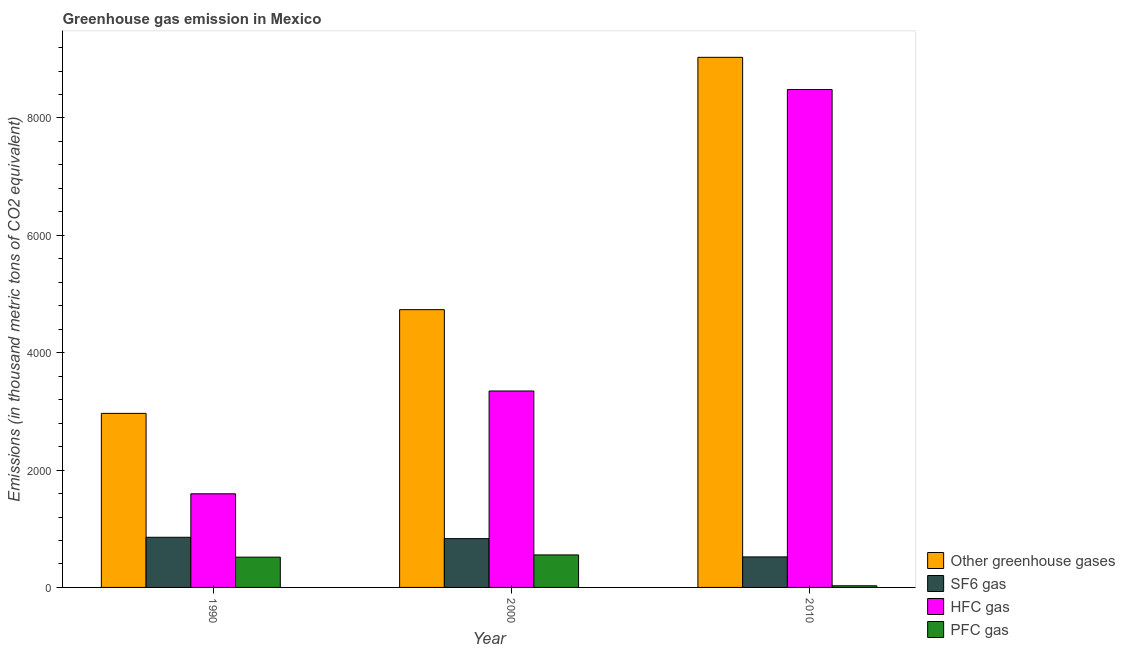How many groups of bars are there?
Offer a terse response. 3. Are the number of bars per tick equal to the number of legend labels?
Provide a short and direct response. Yes. How many bars are there on the 2nd tick from the right?
Offer a very short reply. 4. In how many cases, is the number of bars for a given year not equal to the number of legend labels?
Your response must be concise. 0. What is the emission of greenhouse gases in 1990?
Your answer should be very brief. 2965.8. Across all years, what is the maximum emission of greenhouse gases?
Make the answer very short. 9033. Across all years, what is the minimum emission of sf6 gas?
Provide a short and direct response. 520. In which year was the emission of pfc gas maximum?
Make the answer very short. 2000. What is the total emission of pfc gas in the graph?
Ensure brevity in your answer.  1098.1. What is the difference between the emission of greenhouse gases in 2000 and that in 2010?
Provide a succinct answer. -4299.8. What is the difference between the emission of hfc gas in 2010 and the emission of pfc gas in 1990?
Your response must be concise. 6889.7. What is the average emission of pfc gas per year?
Your response must be concise. 366.03. In how many years, is the emission of pfc gas greater than 5200 thousand metric tons?
Your response must be concise. 0. What is the ratio of the emission of hfc gas in 2000 to that in 2010?
Offer a terse response. 0.39. What is the difference between the highest and the second highest emission of pfc gas?
Provide a short and direct response. 38.1. What is the difference between the highest and the lowest emission of hfc gas?
Your answer should be compact. 6889.7. Is it the case that in every year, the sum of the emission of hfc gas and emission of greenhouse gases is greater than the sum of emission of sf6 gas and emission of pfc gas?
Offer a terse response. No. What does the 3rd bar from the left in 1990 represents?
Make the answer very short. HFC gas. What does the 1st bar from the right in 1990 represents?
Your response must be concise. PFC gas. Is it the case that in every year, the sum of the emission of greenhouse gases and emission of sf6 gas is greater than the emission of hfc gas?
Your response must be concise. Yes. Are all the bars in the graph horizontal?
Your response must be concise. No. Are the values on the major ticks of Y-axis written in scientific E-notation?
Provide a short and direct response. No. Does the graph contain any zero values?
Offer a very short reply. No. How are the legend labels stacked?
Your response must be concise. Vertical. What is the title of the graph?
Make the answer very short. Greenhouse gas emission in Mexico. Does "Rule based governance" appear as one of the legend labels in the graph?
Offer a very short reply. No. What is the label or title of the Y-axis?
Your answer should be very brief. Emissions (in thousand metric tons of CO2 equivalent). What is the Emissions (in thousand metric tons of CO2 equivalent) in Other greenhouse gases in 1990?
Offer a very short reply. 2965.8. What is the Emissions (in thousand metric tons of CO2 equivalent) in SF6 gas in 1990?
Your answer should be very brief. 854.5. What is the Emissions (in thousand metric tons of CO2 equivalent) of HFC gas in 1990?
Provide a succinct answer. 1595.3. What is the Emissions (in thousand metric tons of CO2 equivalent) of PFC gas in 1990?
Keep it short and to the point. 516. What is the Emissions (in thousand metric tons of CO2 equivalent) in Other greenhouse gases in 2000?
Your response must be concise. 4733.2. What is the Emissions (in thousand metric tons of CO2 equivalent) of SF6 gas in 2000?
Your answer should be very brief. 831.8. What is the Emissions (in thousand metric tons of CO2 equivalent) in HFC gas in 2000?
Offer a very short reply. 3347.3. What is the Emissions (in thousand metric tons of CO2 equivalent) in PFC gas in 2000?
Keep it short and to the point. 554.1. What is the Emissions (in thousand metric tons of CO2 equivalent) of Other greenhouse gases in 2010?
Ensure brevity in your answer.  9033. What is the Emissions (in thousand metric tons of CO2 equivalent) in SF6 gas in 2010?
Keep it short and to the point. 520. What is the Emissions (in thousand metric tons of CO2 equivalent) of HFC gas in 2010?
Ensure brevity in your answer.  8485. What is the Emissions (in thousand metric tons of CO2 equivalent) in PFC gas in 2010?
Your response must be concise. 28. Across all years, what is the maximum Emissions (in thousand metric tons of CO2 equivalent) of Other greenhouse gases?
Make the answer very short. 9033. Across all years, what is the maximum Emissions (in thousand metric tons of CO2 equivalent) of SF6 gas?
Give a very brief answer. 854.5. Across all years, what is the maximum Emissions (in thousand metric tons of CO2 equivalent) of HFC gas?
Offer a terse response. 8485. Across all years, what is the maximum Emissions (in thousand metric tons of CO2 equivalent) of PFC gas?
Your answer should be compact. 554.1. Across all years, what is the minimum Emissions (in thousand metric tons of CO2 equivalent) of Other greenhouse gases?
Make the answer very short. 2965.8. Across all years, what is the minimum Emissions (in thousand metric tons of CO2 equivalent) in SF6 gas?
Ensure brevity in your answer.  520. Across all years, what is the minimum Emissions (in thousand metric tons of CO2 equivalent) in HFC gas?
Make the answer very short. 1595.3. Across all years, what is the minimum Emissions (in thousand metric tons of CO2 equivalent) of PFC gas?
Keep it short and to the point. 28. What is the total Emissions (in thousand metric tons of CO2 equivalent) of Other greenhouse gases in the graph?
Make the answer very short. 1.67e+04. What is the total Emissions (in thousand metric tons of CO2 equivalent) of SF6 gas in the graph?
Provide a short and direct response. 2206.3. What is the total Emissions (in thousand metric tons of CO2 equivalent) of HFC gas in the graph?
Your answer should be very brief. 1.34e+04. What is the total Emissions (in thousand metric tons of CO2 equivalent) in PFC gas in the graph?
Ensure brevity in your answer.  1098.1. What is the difference between the Emissions (in thousand metric tons of CO2 equivalent) in Other greenhouse gases in 1990 and that in 2000?
Offer a very short reply. -1767.4. What is the difference between the Emissions (in thousand metric tons of CO2 equivalent) of SF6 gas in 1990 and that in 2000?
Your answer should be compact. 22.7. What is the difference between the Emissions (in thousand metric tons of CO2 equivalent) in HFC gas in 1990 and that in 2000?
Keep it short and to the point. -1752. What is the difference between the Emissions (in thousand metric tons of CO2 equivalent) of PFC gas in 1990 and that in 2000?
Give a very brief answer. -38.1. What is the difference between the Emissions (in thousand metric tons of CO2 equivalent) in Other greenhouse gases in 1990 and that in 2010?
Make the answer very short. -6067.2. What is the difference between the Emissions (in thousand metric tons of CO2 equivalent) of SF6 gas in 1990 and that in 2010?
Give a very brief answer. 334.5. What is the difference between the Emissions (in thousand metric tons of CO2 equivalent) of HFC gas in 1990 and that in 2010?
Your answer should be very brief. -6889.7. What is the difference between the Emissions (in thousand metric tons of CO2 equivalent) in PFC gas in 1990 and that in 2010?
Offer a terse response. 488. What is the difference between the Emissions (in thousand metric tons of CO2 equivalent) in Other greenhouse gases in 2000 and that in 2010?
Your answer should be compact. -4299.8. What is the difference between the Emissions (in thousand metric tons of CO2 equivalent) in SF6 gas in 2000 and that in 2010?
Give a very brief answer. 311.8. What is the difference between the Emissions (in thousand metric tons of CO2 equivalent) in HFC gas in 2000 and that in 2010?
Give a very brief answer. -5137.7. What is the difference between the Emissions (in thousand metric tons of CO2 equivalent) in PFC gas in 2000 and that in 2010?
Offer a very short reply. 526.1. What is the difference between the Emissions (in thousand metric tons of CO2 equivalent) in Other greenhouse gases in 1990 and the Emissions (in thousand metric tons of CO2 equivalent) in SF6 gas in 2000?
Your response must be concise. 2134. What is the difference between the Emissions (in thousand metric tons of CO2 equivalent) of Other greenhouse gases in 1990 and the Emissions (in thousand metric tons of CO2 equivalent) of HFC gas in 2000?
Give a very brief answer. -381.5. What is the difference between the Emissions (in thousand metric tons of CO2 equivalent) in Other greenhouse gases in 1990 and the Emissions (in thousand metric tons of CO2 equivalent) in PFC gas in 2000?
Provide a succinct answer. 2411.7. What is the difference between the Emissions (in thousand metric tons of CO2 equivalent) in SF6 gas in 1990 and the Emissions (in thousand metric tons of CO2 equivalent) in HFC gas in 2000?
Make the answer very short. -2492.8. What is the difference between the Emissions (in thousand metric tons of CO2 equivalent) of SF6 gas in 1990 and the Emissions (in thousand metric tons of CO2 equivalent) of PFC gas in 2000?
Your answer should be compact. 300.4. What is the difference between the Emissions (in thousand metric tons of CO2 equivalent) in HFC gas in 1990 and the Emissions (in thousand metric tons of CO2 equivalent) in PFC gas in 2000?
Your answer should be compact. 1041.2. What is the difference between the Emissions (in thousand metric tons of CO2 equivalent) of Other greenhouse gases in 1990 and the Emissions (in thousand metric tons of CO2 equivalent) of SF6 gas in 2010?
Your response must be concise. 2445.8. What is the difference between the Emissions (in thousand metric tons of CO2 equivalent) of Other greenhouse gases in 1990 and the Emissions (in thousand metric tons of CO2 equivalent) of HFC gas in 2010?
Make the answer very short. -5519.2. What is the difference between the Emissions (in thousand metric tons of CO2 equivalent) in Other greenhouse gases in 1990 and the Emissions (in thousand metric tons of CO2 equivalent) in PFC gas in 2010?
Provide a succinct answer. 2937.8. What is the difference between the Emissions (in thousand metric tons of CO2 equivalent) in SF6 gas in 1990 and the Emissions (in thousand metric tons of CO2 equivalent) in HFC gas in 2010?
Make the answer very short. -7630.5. What is the difference between the Emissions (in thousand metric tons of CO2 equivalent) of SF6 gas in 1990 and the Emissions (in thousand metric tons of CO2 equivalent) of PFC gas in 2010?
Ensure brevity in your answer.  826.5. What is the difference between the Emissions (in thousand metric tons of CO2 equivalent) in HFC gas in 1990 and the Emissions (in thousand metric tons of CO2 equivalent) in PFC gas in 2010?
Keep it short and to the point. 1567.3. What is the difference between the Emissions (in thousand metric tons of CO2 equivalent) of Other greenhouse gases in 2000 and the Emissions (in thousand metric tons of CO2 equivalent) of SF6 gas in 2010?
Your answer should be very brief. 4213.2. What is the difference between the Emissions (in thousand metric tons of CO2 equivalent) of Other greenhouse gases in 2000 and the Emissions (in thousand metric tons of CO2 equivalent) of HFC gas in 2010?
Make the answer very short. -3751.8. What is the difference between the Emissions (in thousand metric tons of CO2 equivalent) of Other greenhouse gases in 2000 and the Emissions (in thousand metric tons of CO2 equivalent) of PFC gas in 2010?
Your answer should be very brief. 4705.2. What is the difference between the Emissions (in thousand metric tons of CO2 equivalent) of SF6 gas in 2000 and the Emissions (in thousand metric tons of CO2 equivalent) of HFC gas in 2010?
Your response must be concise. -7653.2. What is the difference between the Emissions (in thousand metric tons of CO2 equivalent) in SF6 gas in 2000 and the Emissions (in thousand metric tons of CO2 equivalent) in PFC gas in 2010?
Your answer should be very brief. 803.8. What is the difference between the Emissions (in thousand metric tons of CO2 equivalent) in HFC gas in 2000 and the Emissions (in thousand metric tons of CO2 equivalent) in PFC gas in 2010?
Ensure brevity in your answer.  3319.3. What is the average Emissions (in thousand metric tons of CO2 equivalent) in Other greenhouse gases per year?
Make the answer very short. 5577.33. What is the average Emissions (in thousand metric tons of CO2 equivalent) in SF6 gas per year?
Ensure brevity in your answer.  735.43. What is the average Emissions (in thousand metric tons of CO2 equivalent) of HFC gas per year?
Provide a short and direct response. 4475.87. What is the average Emissions (in thousand metric tons of CO2 equivalent) in PFC gas per year?
Your response must be concise. 366.03. In the year 1990, what is the difference between the Emissions (in thousand metric tons of CO2 equivalent) in Other greenhouse gases and Emissions (in thousand metric tons of CO2 equivalent) in SF6 gas?
Provide a short and direct response. 2111.3. In the year 1990, what is the difference between the Emissions (in thousand metric tons of CO2 equivalent) of Other greenhouse gases and Emissions (in thousand metric tons of CO2 equivalent) of HFC gas?
Give a very brief answer. 1370.5. In the year 1990, what is the difference between the Emissions (in thousand metric tons of CO2 equivalent) of Other greenhouse gases and Emissions (in thousand metric tons of CO2 equivalent) of PFC gas?
Keep it short and to the point. 2449.8. In the year 1990, what is the difference between the Emissions (in thousand metric tons of CO2 equivalent) in SF6 gas and Emissions (in thousand metric tons of CO2 equivalent) in HFC gas?
Offer a very short reply. -740.8. In the year 1990, what is the difference between the Emissions (in thousand metric tons of CO2 equivalent) of SF6 gas and Emissions (in thousand metric tons of CO2 equivalent) of PFC gas?
Ensure brevity in your answer.  338.5. In the year 1990, what is the difference between the Emissions (in thousand metric tons of CO2 equivalent) of HFC gas and Emissions (in thousand metric tons of CO2 equivalent) of PFC gas?
Provide a succinct answer. 1079.3. In the year 2000, what is the difference between the Emissions (in thousand metric tons of CO2 equivalent) in Other greenhouse gases and Emissions (in thousand metric tons of CO2 equivalent) in SF6 gas?
Give a very brief answer. 3901.4. In the year 2000, what is the difference between the Emissions (in thousand metric tons of CO2 equivalent) in Other greenhouse gases and Emissions (in thousand metric tons of CO2 equivalent) in HFC gas?
Your answer should be very brief. 1385.9. In the year 2000, what is the difference between the Emissions (in thousand metric tons of CO2 equivalent) in Other greenhouse gases and Emissions (in thousand metric tons of CO2 equivalent) in PFC gas?
Offer a very short reply. 4179.1. In the year 2000, what is the difference between the Emissions (in thousand metric tons of CO2 equivalent) of SF6 gas and Emissions (in thousand metric tons of CO2 equivalent) of HFC gas?
Give a very brief answer. -2515.5. In the year 2000, what is the difference between the Emissions (in thousand metric tons of CO2 equivalent) in SF6 gas and Emissions (in thousand metric tons of CO2 equivalent) in PFC gas?
Provide a succinct answer. 277.7. In the year 2000, what is the difference between the Emissions (in thousand metric tons of CO2 equivalent) of HFC gas and Emissions (in thousand metric tons of CO2 equivalent) of PFC gas?
Your response must be concise. 2793.2. In the year 2010, what is the difference between the Emissions (in thousand metric tons of CO2 equivalent) in Other greenhouse gases and Emissions (in thousand metric tons of CO2 equivalent) in SF6 gas?
Provide a succinct answer. 8513. In the year 2010, what is the difference between the Emissions (in thousand metric tons of CO2 equivalent) of Other greenhouse gases and Emissions (in thousand metric tons of CO2 equivalent) of HFC gas?
Give a very brief answer. 548. In the year 2010, what is the difference between the Emissions (in thousand metric tons of CO2 equivalent) of Other greenhouse gases and Emissions (in thousand metric tons of CO2 equivalent) of PFC gas?
Your answer should be compact. 9005. In the year 2010, what is the difference between the Emissions (in thousand metric tons of CO2 equivalent) of SF6 gas and Emissions (in thousand metric tons of CO2 equivalent) of HFC gas?
Make the answer very short. -7965. In the year 2010, what is the difference between the Emissions (in thousand metric tons of CO2 equivalent) in SF6 gas and Emissions (in thousand metric tons of CO2 equivalent) in PFC gas?
Give a very brief answer. 492. In the year 2010, what is the difference between the Emissions (in thousand metric tons of CO2 equivalent) of HFC gas and Emissions (in thousand metric tons of CO2 equivalent) of PFC gas?
Offer a terse response. 8457. What is the ratio of the Emissions (in thousand metric tons of CO2 equivalent) in Other greenhouse gases in 1990 to that in 2000?
Offer a terse response. 0.63. What is the ratio of the Emissions (in thousand metric tons of CO2 equivalent) in SF6 gas in 1990 to that in 2000?
Offer a very short reply. 1.03. What is the ratio of the Emissions (in thousand metric tons of CO2 equivalent) in HFC gas in 1990 to that in 2000?
Provide a short and direct response. 0.48. What is the ratio of the Emissions (in thousand metric tons of CO2 equivalent) of PFC gas in 1990 to that in 2000?
Your answer should be very brief. 0.93. What is the ratio of the Emissions (in thousand metric tons of CO2 equivalent) of Other greenhouse gases in 1990 to that in 2010?
Provide a succinct answer. 0.33. What is the ratio of the Emissions (in thousand metric tons of CO2 equivalent) of SF6 gas in 1990 to that in 2010?
Make the answer very short. 1.64. What is the ratio of the Emissions (in thousand metric tons of CO2 equivalent) of HFC gas in 1990 to that in 2010?
Give a very brief answer. 0.19. What is the ratio of the Emissions (in thousand metric tons of CO2 equivalent) of PFC gas in 1990 to that in 2010?
Give a very brief answer. 18.43. What is the ratio of the Emissions (in thousand metric tons of CO2 equivalent) in Other greenhouse gases in 2000 to that in 2010?
Your response must be concise. 0.52. What is the ratio of the Emissions (in thousand metric tons of CO2 equivalent) of SF6 gas in 2000 to that in 2010?
Provide a succinct answer. 1.6. What is the ratio of the Emissions (in thousand metric tons of CO2 equivalent) of HFC gas in 2000 to that in 2010?
Make the answer very short. 0.39. What is the ratio of the Emissions (in thousand metric tons of CO2 equivalent) in PFC gas in 2000 to that in 2010?
Your answer should be very brief. 19.79. What is the difference between the highest and the second highest Emissions (in thousand metric tons of CO2 equivalent) in Other greenhouse gases?
Your answer should be compact. 4299.8. What is the difference between the highest and the second highest Emissions (in thousand metric tons of CO2 equivalent) in SF6 gas?
Make the answer very short. 22.7. What is the difference between the highest and the second highest Emissions (in thousand metric tons of CO2 equivalent) of HFC gas?
Your answer should be very brief. 5137.7. What is the difference between the highest and the second highest Emissions (in thousand metric tons of CO2 equivalent) of PFC gas?
Offer a terse response. 38.1. What is the difference between the highest and the lowest Emissions (in thousand metric tons of CO2 equivalent) of Other greenhouse gases?
Offer a very short reply. 6067.2. What is the difference between the highest and the lowest Emissions (in thousand metric tons of CO2 equivalent) of SF6 gas?
Offer a very short reply. 334.5. What is the difference between the highest and the lowest Emissions (in thousand metric tons of CO2 equivalent) of HFC gas?
Offer a terse response. 6889.7. What is the difference between the highest and the lowest Emissions (in thousand metric tons of CO2 equivalent) of PFC gas?
Ensure brevity in your answer.  526.1. 